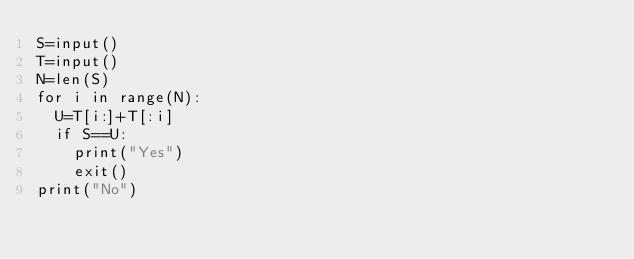Convert code to text. <code><loc_0><loc_0><loc_500><loc_500><_Python_>S=input()
T=input()
N=len(S)
for i in range(N):
  U=T[i:]+T[:i]
  if S==U:
    print("Yes")
    exit()
print("No")
</code> 